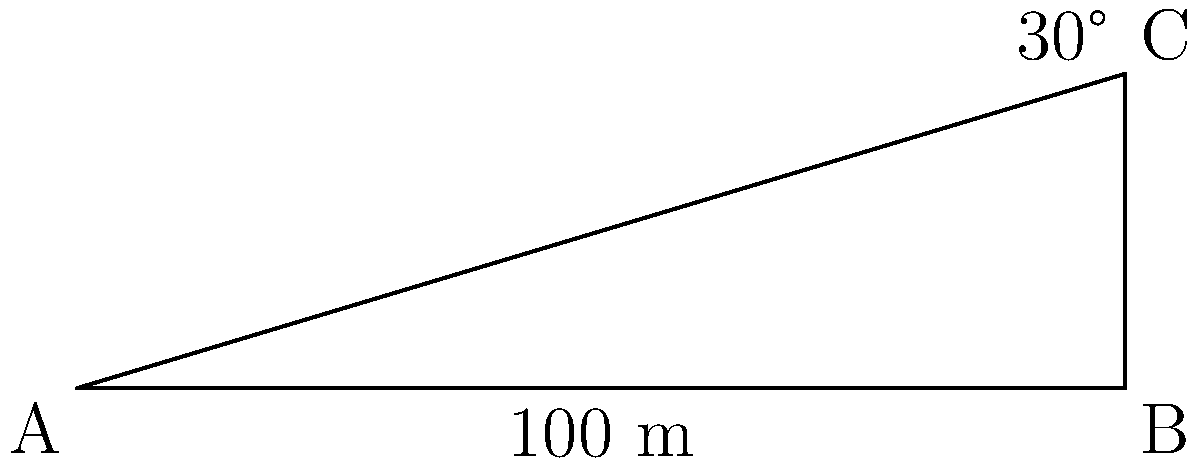Two hospital buildings are connected by an underground tunnel. From the top of one building (point C), you observe the base of the other building (point A) at an angle of 30° below the horizontal. If the distance between the bases of the two buildings is 100 meters, what is the height of the building you're standing on? Let's approach this step-by-step using trigonometric ratios:

1) In the right-angled triangle ABC:
   - The adjacent side (AB) is 100 meters
   - We need to find the opposite side (BC)
   - The angle at C is 30°

2) We can use the tangent ratio:
   
   $\tan \theta = \frac{\text{opposite}}{\text{adjacent}}$

3) Substituting our values:

   $\tan 30° = \frac{BC}{100}$

4) We know that $\tan 30° = \frac{1}{\sqrt{3}}$, so:

   $\frac{1}{\sqrt{3}} = \frac{BC}{100}$

5) Cross multiply:

   $BC \cdot \sqrt{3} = 100$

6) Solve for BC:

   $BC = \frac{100}{\sqrt{3}} \approx 57.74$ meters

Therefore, the height of the building you're standing on is approximately 57.74 meters.
Answer: $\frac{100}{\sqrt{3}}$ meters or approximately 57.74 meters 